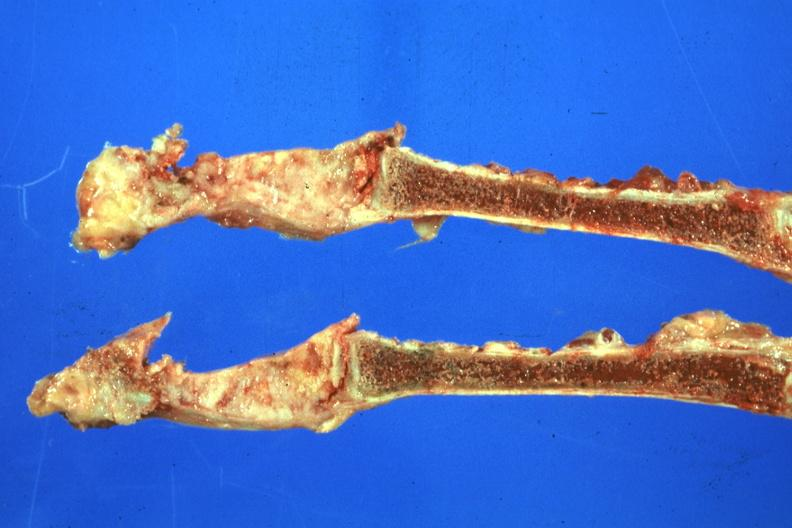what does this image show?
Answer the question using a single word or phrase. Saggital section sternum obvious lesion scar carcinoma 